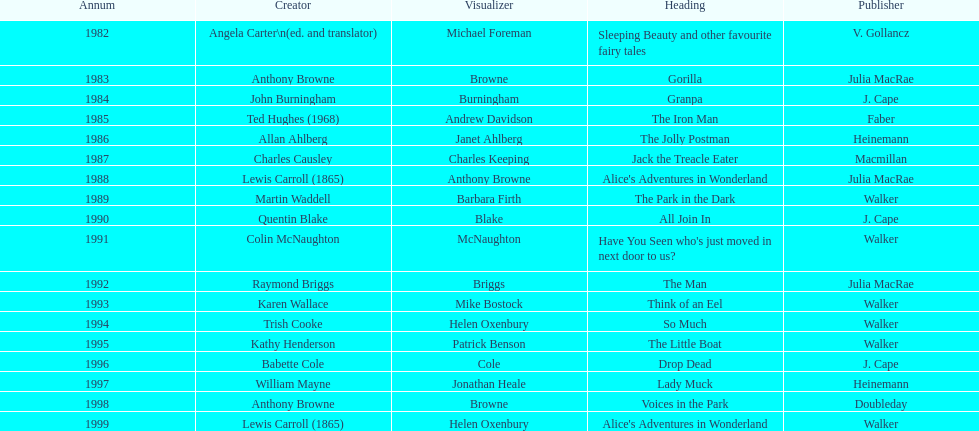Apart from lewis carroll, which other writer has received the kurt maschler award two times? Anthony Browne. 